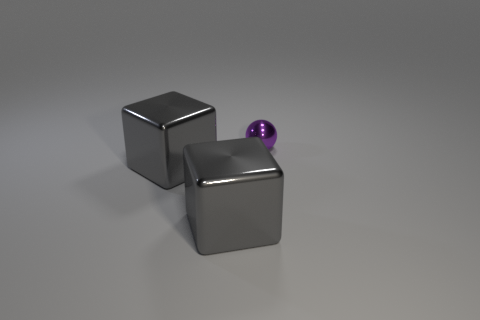Subtract all red spheres. Subtract all blue cylinders. How many spheres are left? 1 Add 1 tiny purple metal spheres. How many objects exist? 4 Subtract all blocks. How many objects are left? 1 Subtract all large objects. Subtract all tiny purple metal things. How many objects are left? 0 Add 1 small purple balls. How many small purple balls are left? 2 Add 1 large things. How many large things exist? 3 Subtract 0 green blocks. How many objects are left? 3 